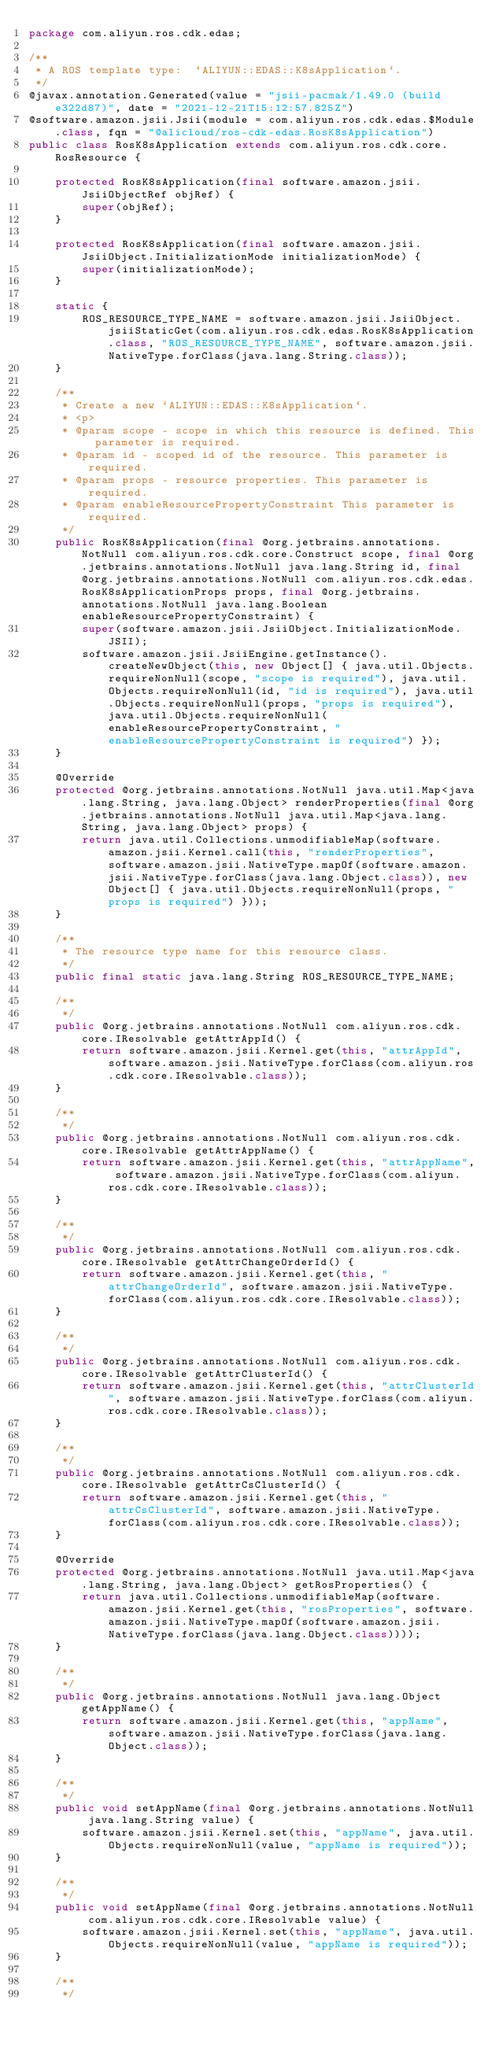Convert code to text. <code><loc_0><loc_0><loc_500><loc_500><_Java_>package com.aliyun.ros.cdk.edas;

/**
 * A ROS template type:  `ALIYUN::EDAS::K8sApplication`.
 */
@javax.annotation.Generated(value = "jsii-pacmak/1.49.0 (build e322d87)", date = "2021-12-21T15:12:57.825Z")
@software.amazon.jsii.Jsii(module = com.aliyun.ros.cdk.edas.$Module.class, fqn = "@alicloud/ros-cdk-edas.RosK8sApplication")
public class RosK8sApplication extends com.aliyun.ros.cdk.core.RosResource {

    protected RosK8sApplication(final software.amazon.jsii.JsiiObjectRef objRef) {
        super(objRef);
    }

    protected RosK8sApplication(final software.amazon.jsii.JsiiObject.InitializationMode initializationMode) {
        super(initializationMode);
    }

    static {
        ROS_RESOURCE_TYPE_NAME = software.amazon.jsii.JsiiObject.jsiiStaticGet(com.aliyun.ros.cdk.edas.RosK8sApplication.class, "ROS_RESOURCE_TYPE_NAME", software.amazon.jsii.NativeType.forClass(java.lang.String.class));
    }

    /**
     * Create a new `ALIYUN::EDAS::K8sApplication`.
     * <p>
     * @param scope - scope in which this resource is defined. This parameter is required.
     * @param id - scoped id of the resource. This parameter is required.
     * @param props - resource properties. This parameter is required.
     * @param enableResourcePropertyConstraint This parameter is required.
     */
    public RosK8sApplication(final @org.jetbrains.annotations.NotNull com.aliyun.ros.cdk.core.Construct scope, final @org.jetbrains.annotations.NotNull java.lang.String id, final @org.jetbrains.annotations.NotNull com.aliyun.ros.cdk.edas.RosK8sApplicationProps props, final @org.jetbrains.annotations.NotNull java.lang.Boolean enableResourcePropertyConstraint) {
        super(software.amazon.jsii.JsiiObject.InitializationMode.JSII);
        software.amazon.jsii.JsiiEngine.getInstance().createNewObject(this, new Object[] { java.util.Objects.requireNonNull(scope, "scope is required"), java.util.Objects.requireNonNull(id, "id is required"), java.util.Objects.requireNonNull(props, "props is required"), java.util.Objects.requireNonNull(enableResourcePropertyConstraint, "enableResourcePropertyConstraint is required") });
    }

    @Override
    protected @org.jetbrains.annotations.NotNull java.util.Map<java.lang.String, java.lang.Object> renderProperties(final @org.jetbrains.annotations.NotNull java.util.Map<java.lang.String, java.lang.Object> props) {
        return java.util.Collections.unmodifiableMap(software.amazon.jsii.Kernel.call(this, "renderProperties", software.amazon.jsii.NativeType.mapOf(software.amazon.jsii.NativeType.forClass(java.lang.Object.class)), new Object[] { java.util.Objects.requireNonNull(props, "props is required") }));
    }

    /**
     * The resource type name for this resource class.
     */
    public final static java.lang.String ROS_RESOURCE_TYPE_NAME;

    /**
     */
    public @org.jetbrains.annotations.NotNull com.aliyun.ros.cdk.core.IResolvable getAttrAppId() {
        return software.amazon.jsii.Kernel.get(this, "attrAppId", software.amazon.jsii.NativeType.forClass(com.aliyun.ros.cdk.core.IResolvable.class));
    }

    /**
     */
    public @org.jetbrains.annotations.NotNull com.aliyun.ros.cdk.core.IResolvable getAttrAppName() {
        return software.amazon.jsii.Kernel.get(this, "attrAppName", software.amazon.jsii.NativeType.forClass(com.aliyun.ros.cdk.core.IResolvable.class));
    }

    /**
     */
    public @org.jetbrains.annotations.NotNull com.aliyun.ros.cdk.core.IResolvable getAttrChangeOrderId() {
        return software.amazon.jsii.Kernel.get(this, "attrChangeOrderId", software.amazon.jsii.NativeType.forClass(com.aliyun.ros.cdk.core.IResolvable.class));
    }

    /**
     */
    public @org.jetbrains.annotations.NotNull com.aliyun.ros.cdk.core.IResolvable getAttrClusterId() {
        return software.amazon.jsii.Kernel.get(this, "attrClusterId", software.amazon.jsii.NativeType.forClass(com.aliyun.ros.cdk.core.IResolvable.class));
    }

    /**
     */
    public @org.jetbrains.annotations.NotNull com.aliyun.ros.cdk.core.IResolvable getAttrCsClusterId() {
        return software.amazon.jsii.Kernel.get(this, "attrCsClusterId", software.amazon.jsii.NativeType.forClass(com.aliyun.ros.cdk.core.IResolvable.class));
    }

    @Override
    protected @org.jetbrains.annotations.NotNull java.util.Map<java.lang.String, java.lang.Object> getRosProperties() {
        return java.util.Collections.unmodifiableMap(software.amazon.jsii.Kernel.get(this, "rosProperties", software.amazon.jsii.NativeType.mapOf(software.amazon.jsii.NativeType.forClass(java.lang.Object.class))));
    }

    /**
     */
    public @org.jetbrains.annotations.NotNull java.lang.Object getAppName() {
        return software.amazon.jsii.Kernel.get(this, "appName", software.amazon.jsii.NativeType.forClass(java.lang.Object.class));
    }

    /**
     */
    public void setAppName(final @org.jetbrains.annotations.NotNull java.lang.String value) {
        software.amazon.jsii.Kernel.set(this, "appName", java.util.Objects.requireNonNull(value, "appName is required"));
    }

    /**
     */
    public void setAppName(final @org.jetbrains.annotations.NotNull com.aliyun.ros.cdk.core.IResolvable value) {
        software.amazon.jsii.Kernel.set(this, "appName", java.util.Objects.requireNonNull(value, "appName is required"));
    }

    /**
     */</code> 